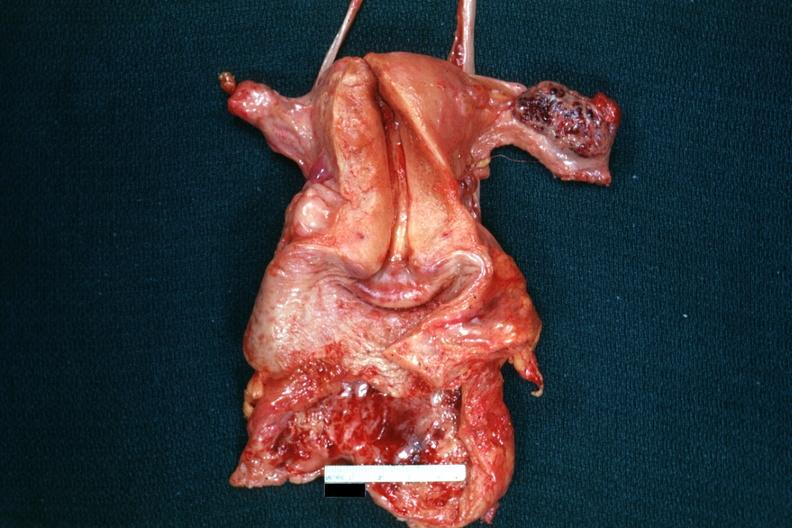what is present?
Answer the question using a single word or phrase. Hemorrhagic corpus luteum 